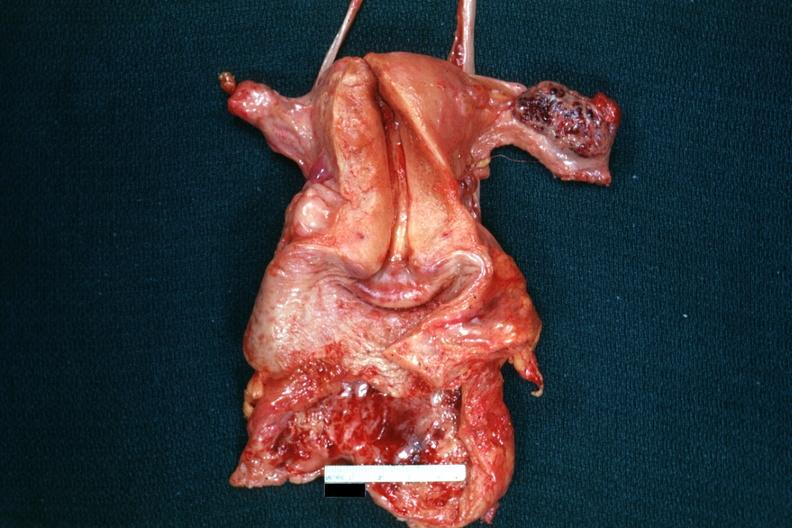what is present?
Answer the question using a single word or phrase. Hemorrhagic corpus luteum 